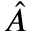Convert formula to latex. <formula><loc_0><loc_0><loc_500><loc_500>\hat { A }</formula> 